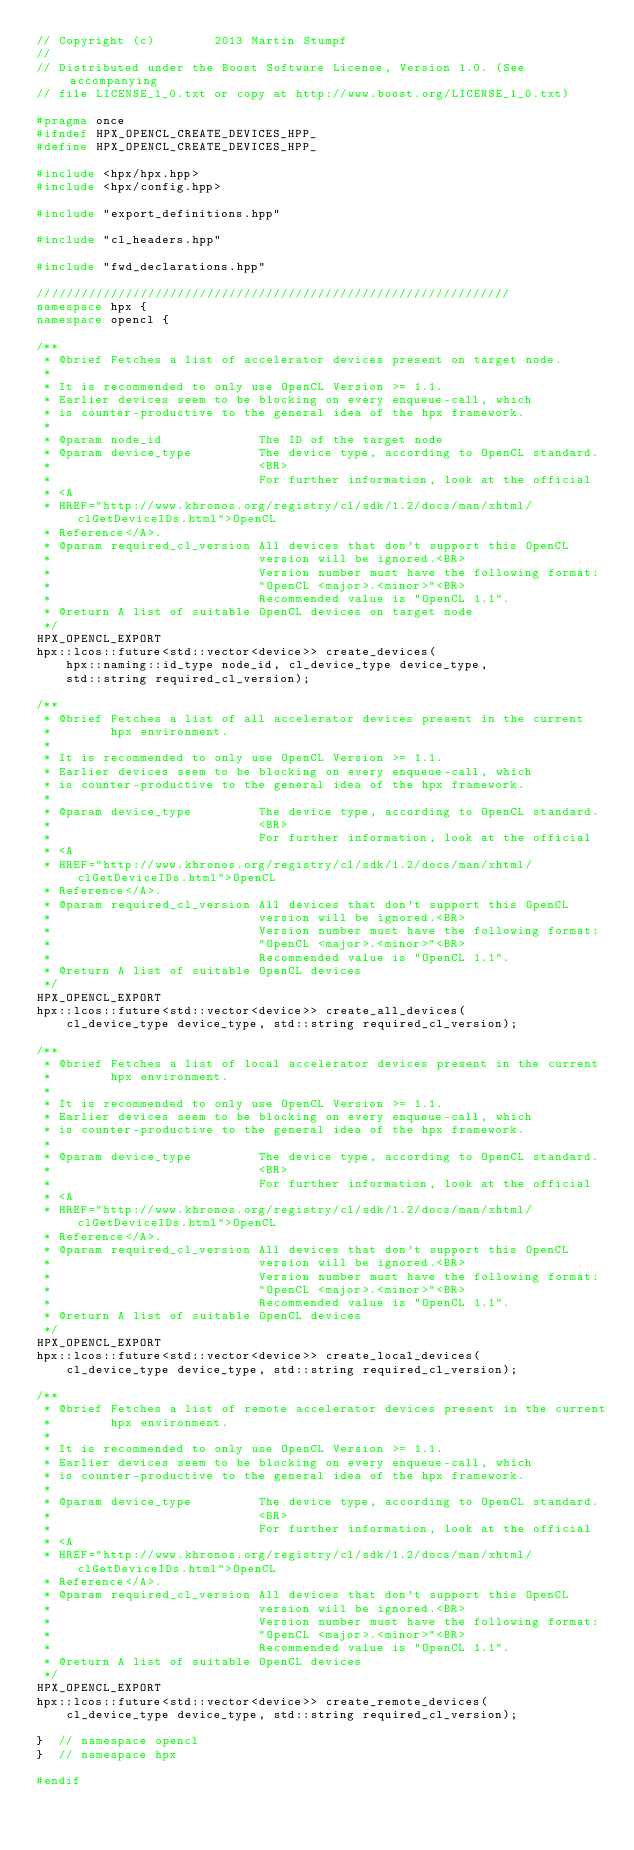Convert code to text. <code><loc_0><loc_0><loc_500><loc_500><_C++_>// Copyright (c)        2013 Martin Stumpf
//
// Distributed under the Boost Software License, Version 1.0. (See accompanying
// file LICENSE_1_0.txt or copy at http://www.boost.org/LICENSE_1_0.txt)

#pragma once
#ifndef HPX_OPENCL_CREATE_DEVICES_HPP_
#define HPX_OPENCL_CREATE_DEVICES_HPP_

#include <hpx/hpx.hpp>
#include <hpx/config.hpp>

#include "export_definitions.hpp"

#include "cl_headers.hpp"

#include "fwd_declarations.hpp"

////////////////////////////////////////////////////////////////
namespace hpx {
namespace opencl {

/**
 * @brief Fetches a list of accelerator devices present on target node.
 *
 * It is recommended to only use OpenCL Version >= 1.1.
 * Earlier devices seem to be blocking on every enqueue-call, which
 * is counter-productive to the general idea of the hpx framework.
 *
 * @param node_id             The ID of the target node
 * @param device_type         The device type, according to OpenCL standard.
 *                            <BR>
 *                            For further information, look at the official
 * <A
 * HREF="http://www.khronos.org/registry/cl/sdk/1.2/docs/man/xhtml/clGetDeviceIDs.html">OpenCL
 * Reference</A>.
 * @param required_cl_version All devices that don't support this OpenCL
 *                            version will be ignored.<BR>
 *                            Version number must have the following format:
 *                            "OpenCL <major>.<minor>"<BR>
 *                            Recommended value is "OpenCL 1.1".
 * @return A list of suitable OpenCL devices on target node
 */
HPX_OPENCL_EXPORT
hpx::lcos::future<std::vector<device>> create_devices(
    hpx::naming::id_type node_id, cl_device_type device_type,
    std::string required_cl_version);

/**
 * @brief Fetches a list of all accelerator devices present in the current
 *        hpx environment.
 *
 * It is recommended to only use OpenCL Version >= 1.1.
 * Earlier devices seem to be blocking on every enqueue-call, which
 * is counter-productive to the general idea of the hpx framework.
 *
 * @param device_type         The device type, according to OpenCL standard.
 *                            <BR>
 *                            For further information, look at the official
 * <A
 * HREF="http://www.khronos.org/registry/cl/sdk/1.2/docs/man/xhtml/clGetDeviceIDs.html">OpenCL
 * Reference</A>.
 * @param required_cl_version All devices that don't support this OpenCL
 *                            version will be ignored.<BR>
 *                            Version number must have the following format:
 *                            "OpenCL <major>.<minor>"<BR>
 *                            Recommended value is "OpenCL 1.1".
 * @return A list of suitable OpenCL devices
 */
HPX_OPENCL_EXPORT
hpx::lcos::future<std::vector<device>> create_all_devices(
    cl_device_type device_type, std::string required_cl_version);

/**
 * @brief Fetches a list of local accelerator devices present in the current
 *        hpx environment.
 *
 * It is recommended to only use OpenCL Version >= 1.1.
 * Earlier devices seem to be blocking on every enqueue-call, which
 * is counter-productive to the general idea of the hpx framework.
 *
 * @param device_type         The device type, according to OpenCL standard.
 *                            <BR>
 *                            For further information, look at the official
 * <A
 * HREF="http://www.khronos.org/registry/cl/sdk/1.2/docs/man/xhtml/clGetDeviceIDs.html">OpenCL
 * Reference</A>.
 * @param required_cl_version All devices that don't support this OpenCL
 *                            version will be ignored.<BR>
 *                            Version number must have the following format:
 *                            "OpenCL <major>.<minor>"<BR>
 *                            Recommended value is "OpenCL 1.1".
 * @return A list of suitable OpenCL devices
 */
HPX_OPENCL_EXPORT
hpx::lcos::future<std::vector<device>> create_local_devices(
    cl_device_type device_type, std::string required_cl_version);

/**
 * @brief Fetches a list of remote accelerator devices present in the current
 *        hpx environment.
 *
 * It is recommended to only use OpenCL Version >= 1.1.
 * Earlier devices seem to be blocking on every enqueue-call, which
 * is counter-productive to the general idea of the hpx framework.
 *
 * @param device_type         The device type, according to OpenCL standard.
 *                            <BR>
 *                            For further information, look at the official
 * <A
 * HREF="http://www.khronos.org/registry/cl/sdk/1.2/docs/man/xhtml/clGetDeviceIDs.html">OpenCL
 * Reference</A>.
 * @param required_cl_version All devices that don't support this OpenCL
 *                            version will be ignored.<BR>
 *                            Version number must have the following format:
 *                            "OpenCL <major>.<minor>"<BR>
 *                            Recommended value is "OpenCL 1.1".
 * @return A list of suitable OpenCL devices
 */
HPX_OPENCL_EXPORT
hpx::lcos::future<std::vector<device>> create_remote_devices(
    cl_device_type device_type, std::string required_cl_version);

}  // namespace opencl
}  // namespace hpx

#endif
</code> 